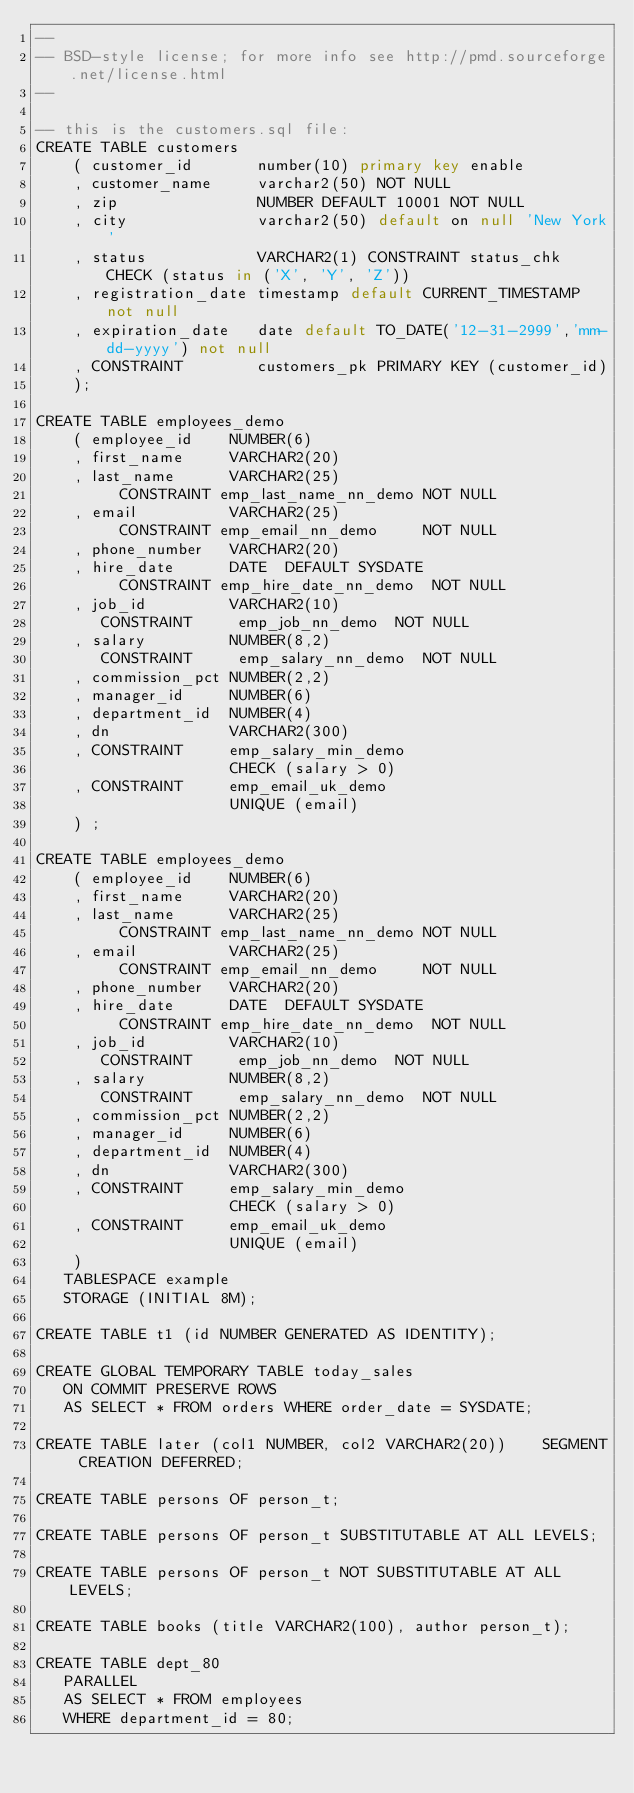Convert code to text. <code><loc_0><loc_0><loc_500><loc_500><_SQL_>--
-- BSD-style license; for more info see http://pmd.sourceforge.net/license.html
--

-- this is the customers.sql file:
CREATE TABLE customers
    ( customer_id       number(10) primary key enable
    , customer_name     varchar2(50) NOT NULL
    , zip               NUMBER DEFAULT 10001 NOT NULL
    , city              varchar2(50) default on null 'New York'
    , status            VARCHAR2(1) CONSTRAINT status_chk CHECK (status in ('X', 'Y', 'Z'))
    , registration_date timestamp default CURRENT_TIMESTAMP not null
    , expiration_date   date default TO_DATE('12-31-2999','mm-dd-yyyy') not null
    , CONSTRAINT        customers_pk PRIMARY KEY (customer_id)
    );

CREATE TABLE employees_demo
    ( employee_id    NUMBER(6)
    , first_name     VARCHAR2(20)
    , last_name      VARCHAR2(25)
         CONSTRAINT emp_last_name_nn_demo NOT NULL
    , email          VARCHAR2(25)
         CONSTRAINT emp_email_nn_demo     NOT NULL
    , phone_number   VARCHAR2(20)
    , hire_date      DATE  DEFAULT SYSDATE
         CONSTRAINT emp_hire_date_nn_demo  NOT NULL
    , job_id         VARCHAR2(10)
       CONSTRAINT     emp_job_nn_demo  NOT NULL
    , salary         NUMBER(8,2)
       CONSTRAINT     emp_salary_nn_demo  NOT NULL
    , commission_pct NUMBER(2,2)
    , manager_id     NUMBER(6)
    , department_id  NUMBER(4)
    , dn             VARCHAR2(300)
    , CONSTRAINT     emp_salary_min_demo
                     CHECK (salary > 0)
    , CONSTRAINT     emp_email_uk_demo
                     UNIQUE (email)
    ) ;

CREATE TABLE employees_demo
    ( employee_id    NUMBER(6)
    , first_name     VARCHAR2(20)
    , last_name      VARCHAR2(25)
         CONSTRAINT emp_last_name_nn_demo NOT NULL
    , email          VARCHAR2(25)
         CONSTRAINT emp_email_nn_demo     NOT NULL
    , phone_number   VARCHAR2(20)
    , hire_date      DATE  DEFAULT SYSDATE
         CONSTRAINT emp_hire_date_nn_demo  NOT NULL
    , job_id         VARCHAR2(10)
       CONSTRAINT     emp_job_nn_demo  NOT NULL
    , salary         NUMBER(8,2)
       CONSTRAINT     emp_salary_nn_demo  NOT NULL
    , commission_pct NUMBER(2,2)
    , manager_id     NUMBER(6)
    , department_id  NUMBER(4)
    , dn             VARCHAR2(300)
    , CONSTRAINT     emp_salary_min_demo
                     CHECK (salary > 0)
    , CONSTRAINT     emp_email_uk_demo
                     UNIQUE (email)
    )
   TABLESPACE example
   STORAGE (INITIAL 8M);

CREATE TABLE t1 (id NUMBER GENERATED AS IDENTITY);

CREATE GLOBAL TEMPORARY TABLE today_sales
   ON COMMIT PRESERVE ROWS
   AS SELECT * FROM orders WHERE order_date = SYSDATE;

CREATE TABLE later (col1 NUMBER, col2 VARCHAR2(20))    SEGMENT CREATION DEFERRED;

CREATE TABLE persons OF person_t;

CREATE TABLE persons OF person_t SUBSTITUTABLE AT ALL LEVELS;

CREATE TABLE persons OF person_t NOT SUBSTITUTABLE AT ALL LEVELS;

CREATE TABLE books (title VARCHAR2(100), author person_t);

CREATE TABLE dept_80
   PARALLEL
   AS SELECT * FROM employees
   WHERE department_id = 80;
</code> 